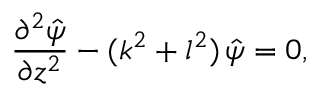<formula> <loc_0><loc_0><loc_500><loc_500>\frac { \partial ^ { 2 } \hat { \psi } } { \partial z ^ { 2 } } - ( k ^ { 2 } + l ^ { 2 } ) \, \hat { \psi } = 0 ,</formula> 